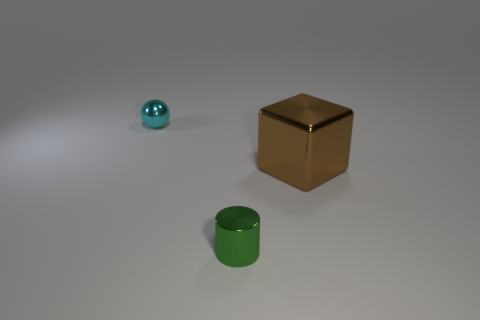Is the number of large brown shiny cubes that are right of the big metal thing greater than the number of balls behind the green metallic thing?
Your answer should be very brief. No. There is a thing behind the cube; how many small cyan spheres are in front of it?
Keep it short and to the point. 0. What number of objects are brown metallic cubes or large red matte cylinders?
Give a very brief answer. 1. Is the big brown metal object the same shape as the green metallic object?
Your answer should be very brief. No. How many tiny things are in front of the cyan thing and behind the green shiny cylinder?
Keep it short and to the point. 0. Do the cyan shiny object and the metal cylinder have the same size?
Offer a terse response. Yes. Is the size of the shiny thing that is on the left side of the shiny cylinder the same as the brown object?
Your answer should be very brief. No. The metallic thing that is behind the big object is what color?
Provide a succinct answer. Cyan. How many big purple matte cubes are there?
Your answer should be compact. 0. The brown object that is the same material as the tiny ball is what shape?
Give a very brief answer. Cube. 